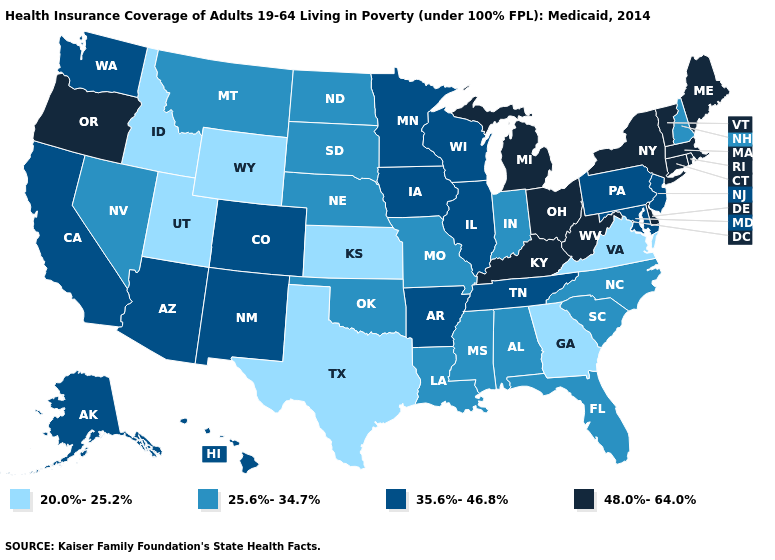Which states have the lowest value in the USA?
Quick response, please. Georgia, Idaho, Kansas, Texas, Utah, Virginia, Wyoming. Name the states that have a value in the range 25.6%-34.7%?
Keep it brief. Alabama, Florida, Indiana, Louisiana, Mississippi, Missouri, Montana, Nebraska, Nevada, New Hampshire, North Carolina, North Dakota, Oklahoma, South Carolina, South Dakota. What is the value of Colorado?
Be succinct. 35.6%-46.8%. How many symbols are there in the legend?
Quick response, please. 4. Name the states that have a value in the range 20.0%-25.2%?
Write a very short answer. Georgia, Idaho, Kansas, Texas, Utah, Virginia, Wyoming. Name the states that have a value in the range 48.0%-64.0%?
Be succinct. Connecticut, Delaware, Kentucky, Maine, Massachusetts, Michigan, New York, Ohio, Oregon, Rhode Island, Vermont, West Virginia. Name the states that have a value in the range 35.6%-46.8%?
Be succinct. Alaska, Arizona, Arkansas, California, Colorado, Hawaii, Illinois, Iowa, Maryland, Minnesota, New Jersey, New Mexico, Pennsylvania, Tennessee, Washington, Wisconsin. What is the lowest value in the USA?
Quick response, please. 20.0%-25.2%. Name the states that have a value in the range 35.6%-46.8%?
Concise answer only. Alaska, Arizona, Arkansas, California, Colorado, Hawaii, Illinois, Iowa, Maryland, Minnesota, New Jersey, New Mexico, Pennsylvania, Tennessee, Washington, Wisconsin. Which states have the highest value in the USA?
Keep it brief. Connecticut, Delaware, Kentucky, Maine, Massachusetts, Michigan, New York, Ohio, Oregon, Rhode Island, Vermont, West Virginia. What is the value of South Dakota?
Short answer required. 25.6%-34.7%. Does Missouri have a higher value than New Mexico?
Concise answer only. No. Does the map have missing data?
Give a very brief answer. No. What is the value of Kentucky?
Quick response, please. 48.0%-64.0%. Name the states that have a value in the range 48.0%-64.0%?
Quick response, please. Connecticut, Delaware, Kentucky, Maine, Massachusetts, Michigan, New York, Ohio, Oregon, Rhode Island, Vermont, West Virginia. 